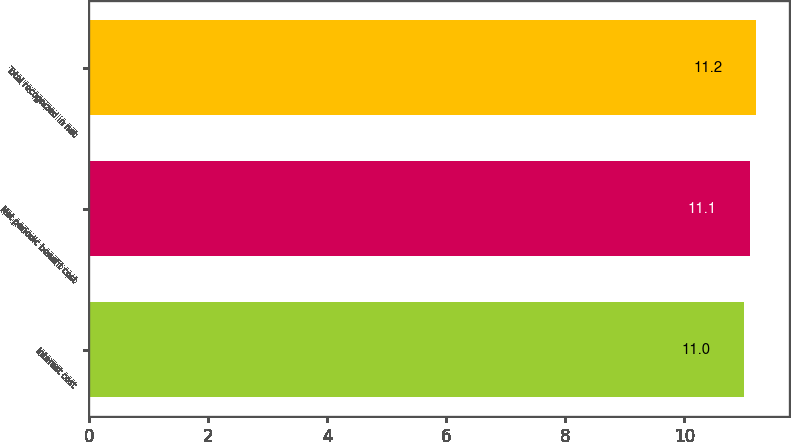Convert chart to OTSL. <chart><loc_0><loc_0><loc_500><loc_500><bar_chart><fcel>Interest cost<fcel>Net periodic benefit cost<fcel>Total recognized in net<nl><fcel>11<fcel>11.1<fcel>11.2<nl></chart> 